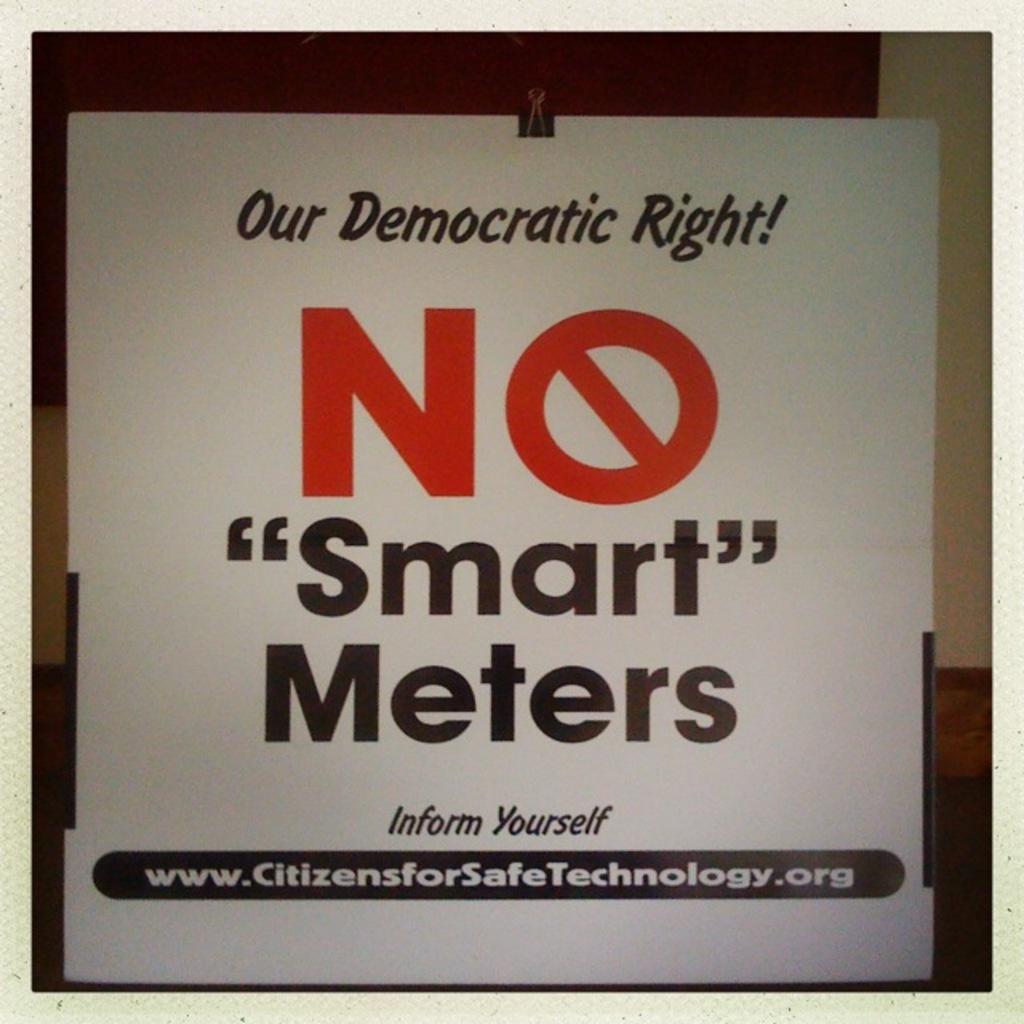In one or two sentences, can you explain what this image depicts? In the center of this picture we can see a white color poster on which we can see the text. In the background we can see the wall. 